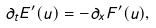Convert formula to latex. <formula><loc_0><loc_0><loc_500><loc_500>\partial _ { t } E ^ { \prime } ( u ) = - \partial _ { x } F ^ { \prime } ( u ) ,</formula> 